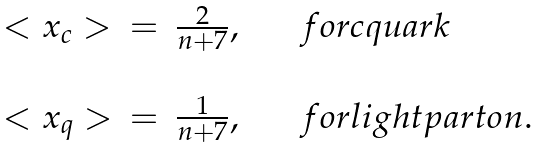<formula> <loc_0><loc_0><loc_500><loc_500>\begin{array} { l l l } < x _ { c } > & = & \frac { 2 } { n + 7 } , \quad \ \ { f o r c q u a r k } \\ \\ < x _ { q } > & = & \frac { 1 } { n + 7 } , \quad \ \ { f o r l i g h t p a r t o n } . \\ \end{array}</formula> 